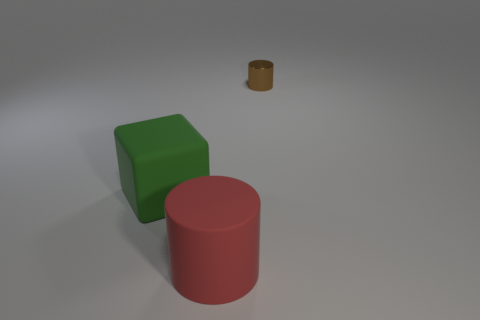Is there anything else that is the same size as the brown cylinder?
Make the answer very short. No. Are there any things on the left side of the big red matte object?
Make the answer very short. Yes. What number of tiny metallic cylinders are behind the rubber object in front of the big green matte object?
Make the answer very short. 1. There is a green cube; is it the same size as the object that is in front of the green matte thing?
Provide a succinct answer. Yes. Are there any matte cylinders that have the same color as the metal cylinder?
Your answer should be very brief. No. What size is the green thing that is made of the same material as the big red cylinder?
Your response must be concise. Large. Do the brown thing and the big cylinder have the same material?
Your answer should be compact. No. What is the color of the rubber object that is behind the big rubber object on the right side of the big matte object that is left of the red rubber object?
Your response must be concise. Green. What is the shape of the green object?
Your answer should be compact. Cube. There is a cube; does it have the same color as the cylinder to the left of the tiny metallic cylinder?
Ensure brevity in your answer.  No. 